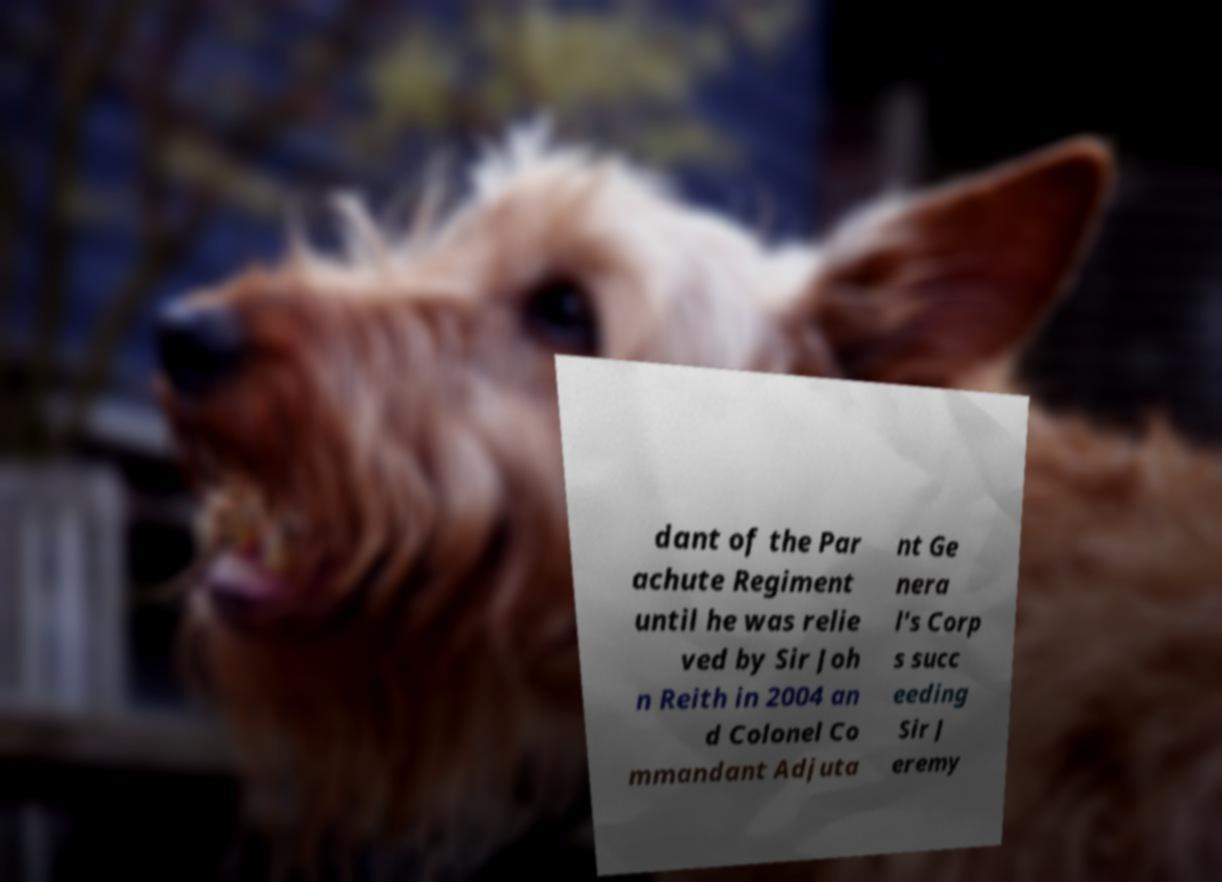Could you extract and type out the text from this image? dant of the Par achute Regiment until he was relie ved by Sir Joh n Reith in 2004 an d Colonel Co mmandant Adjuta nt Ge nera l's Corp s succ eeding Sir J eremy 